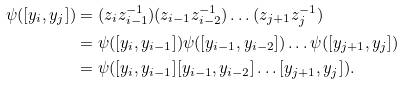Convert formula to latex. <formula><loc_0><loc_0><loc_500><loc_500>\psi ( [ y _ { i } , y _ { j } ] ) & = ( z _ { i } z _ { i - 1 } ^ { - 1 } ) ( z _ { i - 1 } z _ { i - 2 } ^ { - 1 } ) \dots ( z _ { j + 1 } z _ { j } ^ { - 1 } ) \\ & = \psi ( [ y _ { i } , y _ { i - 1 } ] ) \psi ( [ y _ { i - 1 } , y _ { i - 2 } ] ) \dots \psi ( [ y _ { j + 1 } , y _ { j } ] ) \\ & = \psi ( [ y _ { i } , y _ { i - 1 } ] [ y _ { i - 1 } , y _ { i - 2 } ] \dots [ y _ { j + 1 } , y _ { j } ] ) .</formula> 